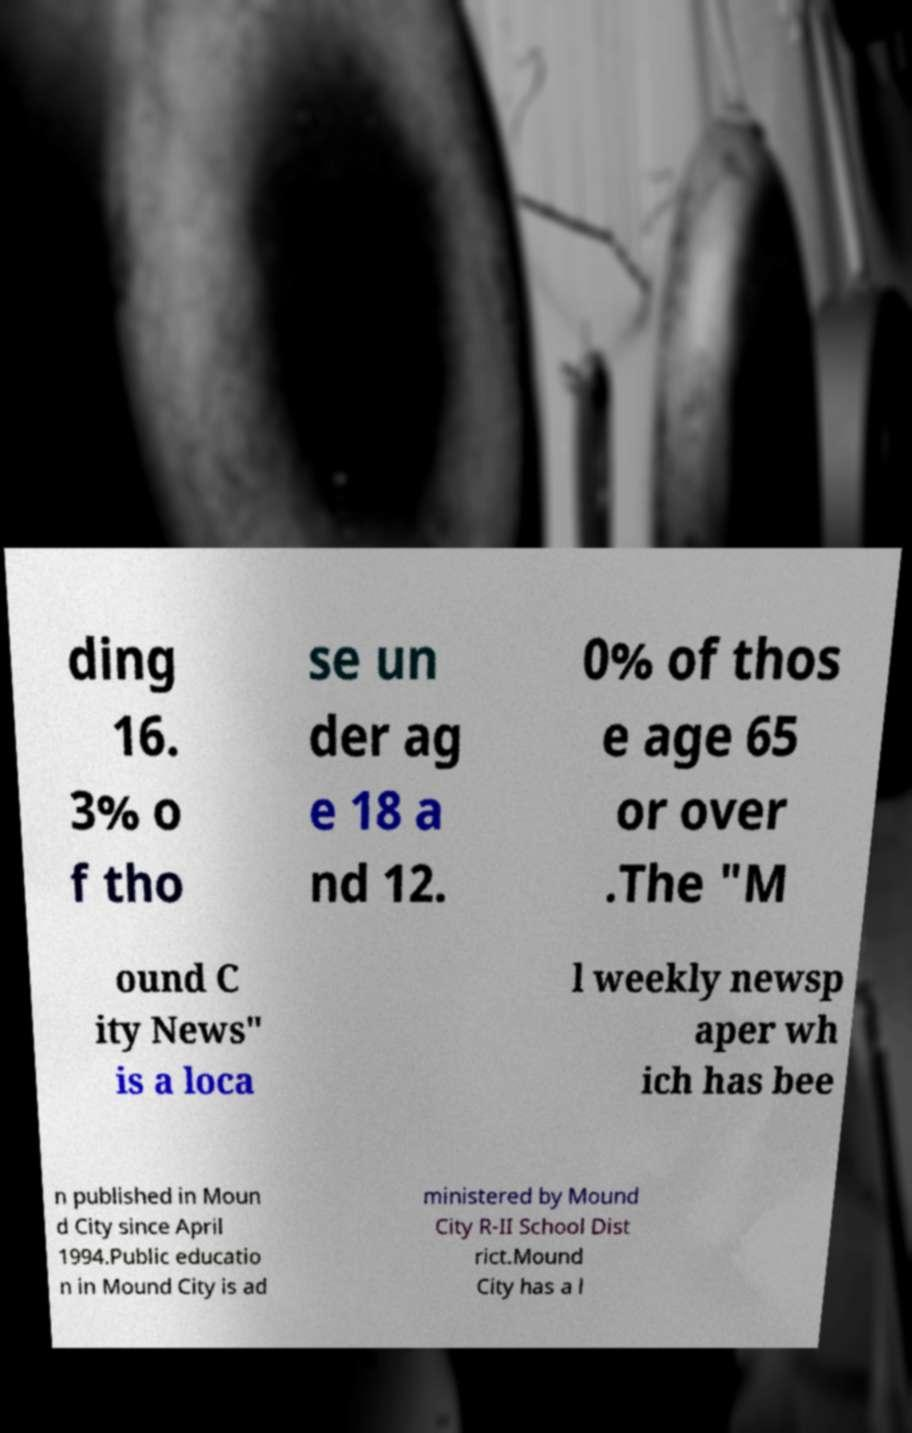There's text embedded in this image that I need extracted. Can you transcribe it verbatim? ding 16. 3% o f tho se un der ag e 18 a nd 12. 0% of thos e age 65 or over .The "M ound C ity News" is a loca l weekly newsp aper wh ich has bee n published in Moun d City since April 1994.Public educatio n in Mound City is ad ministered by Mound City R-II School Dist rict.Mound City has a l 